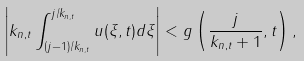<formula> <loc_0><loc_0><loc_500><loc_500>\left | k _ { n , t } \int _ { ( j - 1 ) / k _ { n , t } } ^ { j / k _ { n , t } } u ( \xi , t ) d \xi \right | < g \left ( \frac { j } { k _ { n , t } + 1 } , t \right ) ,</formula> 